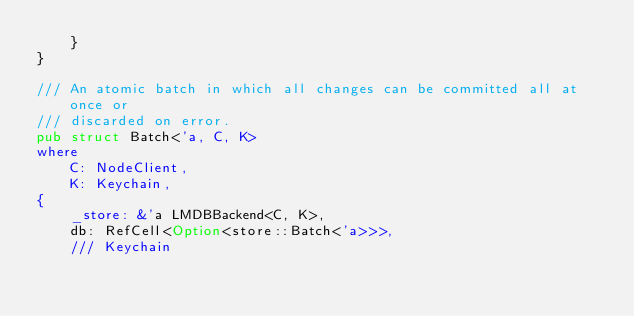<code> <loc_0><loc_0><loc_500><loc_500><_Rust_>	}
}

/// An atomic batch in which all changes can be committed all at once or
/// discarded on error.
pub struct Batch<'a, C, K>
where
	C: NodeClient,
	K: Keychain,
{
	_store: &'a LMDBBackend<C, K>,
	db: RefCell<Option<store::Batch<'a>>>,
	/// Keychain</code> 